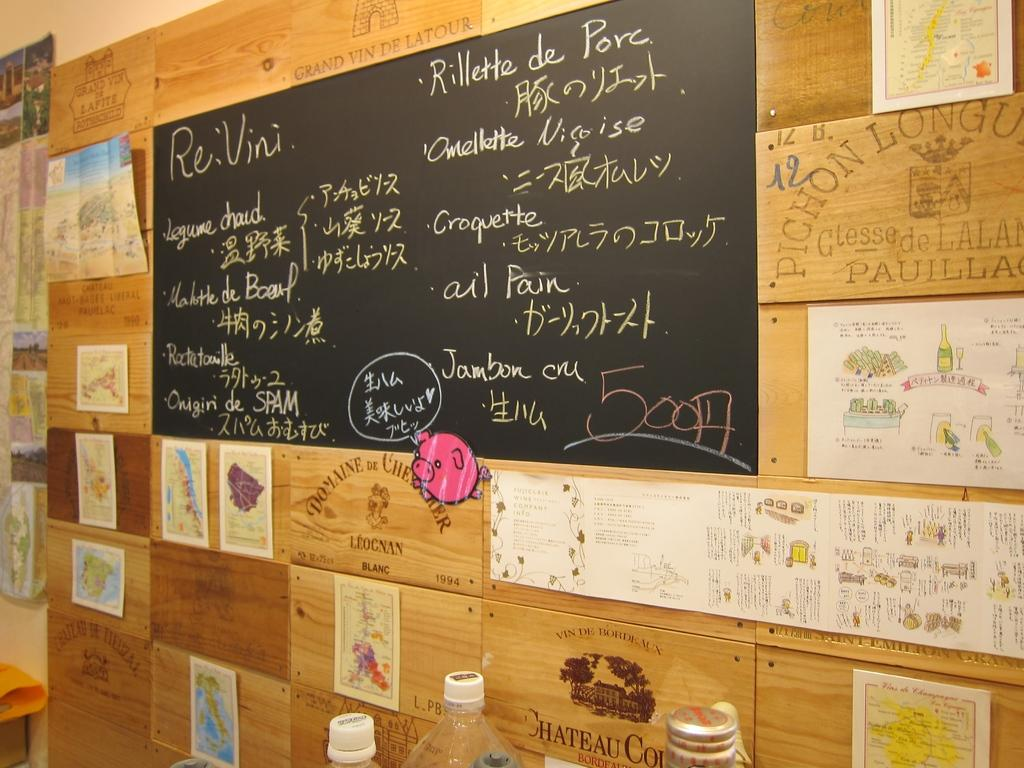<image>
Provide a brief description of the given image. A blackboard that says 50014 in the bottom right corner of it. 